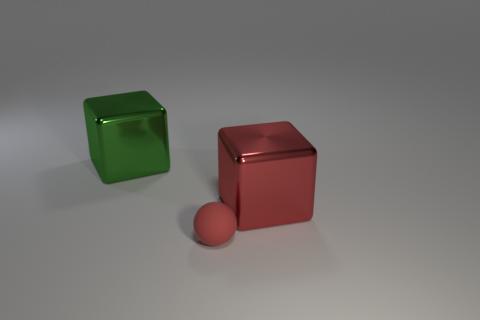Add 1 tiny objects. How many objects exist? 4 Subtract all cubes. How many objects are left? 1 Add 3 big yellow cylinders. How many big yellow cylinders exist? 3 Subtract 0 red cylinders. How many objects are left? 3 Subtract all big yellow shiny cylinders. Subtract all matte balls. How many objects are left? 2 Add 1 small red rubber spheres. How many small red rubber spheres are left? 2 